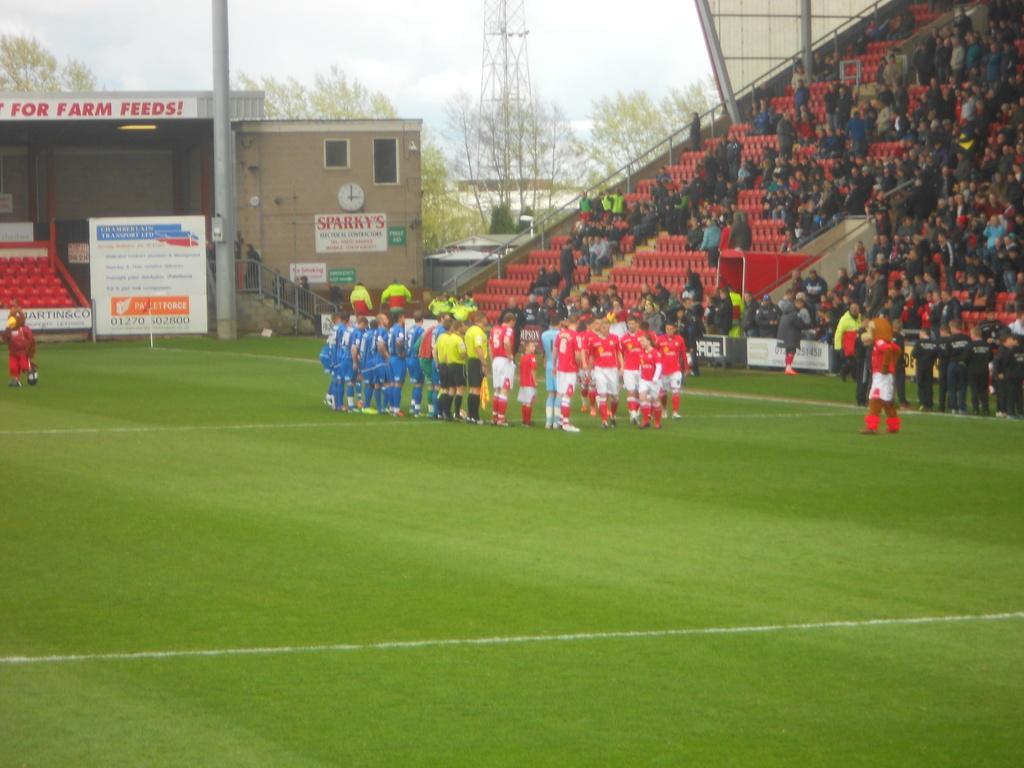In one or two sentences, can you explain what this image depicts? In this image we can see the stadium and there are a few people standing on the ground and a few people sitting in the stadium and there are boards with text and at the left side, we can see the shed, tower and railing. We can see the sky in the background. 